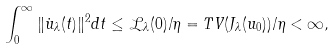Convert formula to latex. <formula><loc_0><loc_0><loc_500><loc_500>\int ^ { \infty } _ { 0 } \| \dot { u } _ { \lambda } ( t ) \| ^ { 2 } d t \leq \mathcal { L } _ { \lambda } ( 0 ) / \eta = T V ( J _ { \lambda } ( u _ { 0 } ) ) / \eta < \infty ,</formula> 